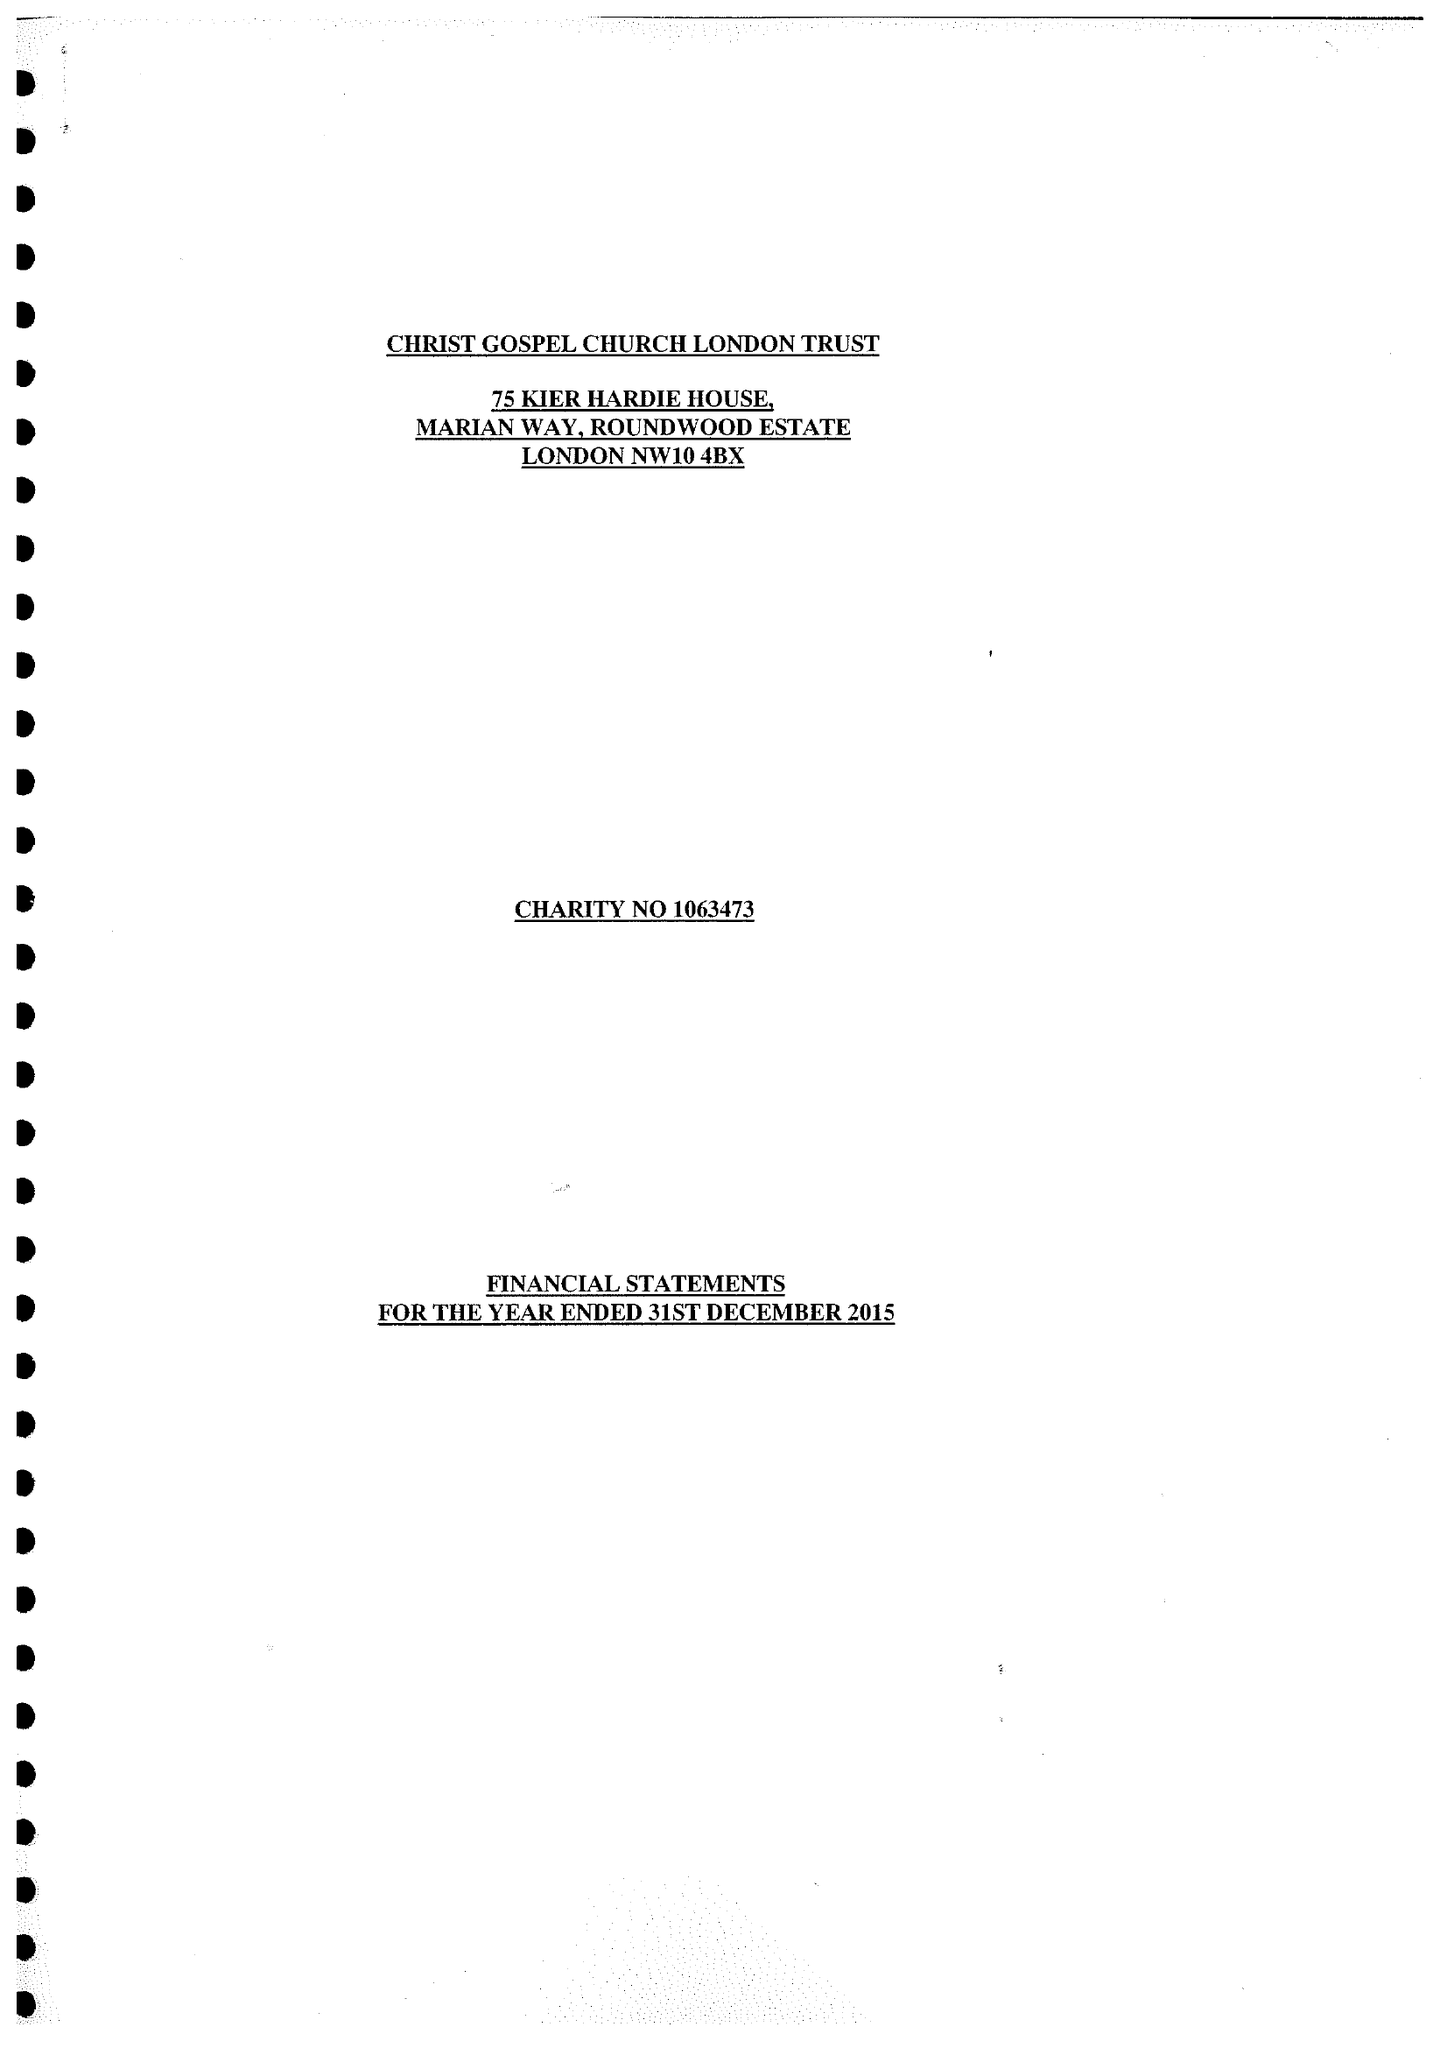What is the value for the spending_annually_in_british_pounds?
Answer the question using a single word or phrase. 18485.00 